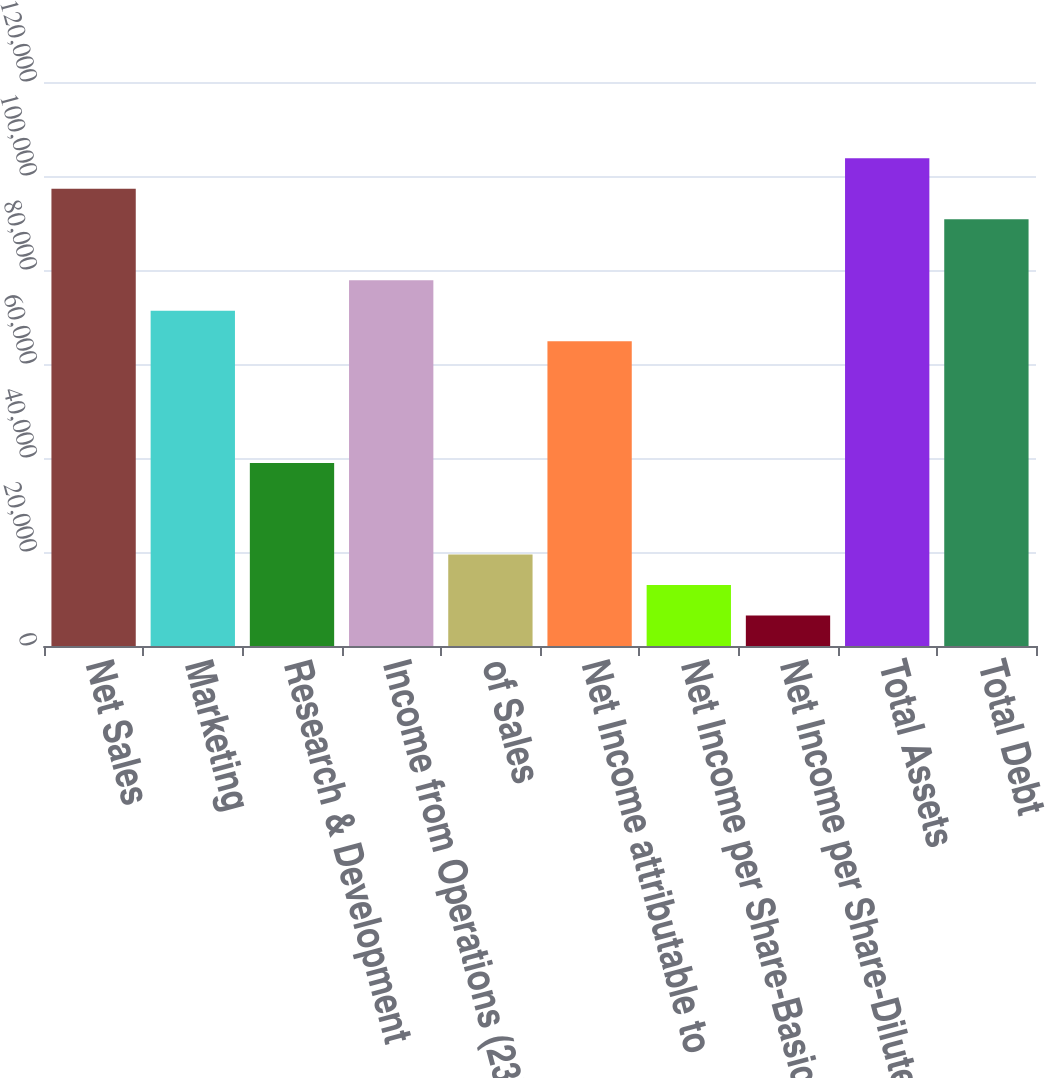Convert chart. <chart><loc_0><loc_0><loc_500><loc_500><bar_chart><fcel>Net Sales<fcel>Marketing<fcel>Research & Development<fcel>Income from Operations (23)<fcel>of Sales<fcel>Net Income attributable to<fcel>Net Income per Share-Basic<fcel>Net Income per Share-Diluted<fcel>Total Assets<fcel>Total Debt<nl><fcel>97283.8<fcel>71341.5<fcel>38913.7<fcel>77827.1<fcel>19457<fcel>64856<fcel>12971.4<fcel>6485.83<fcel>103769<fcel>90798.2<nl></chart> 